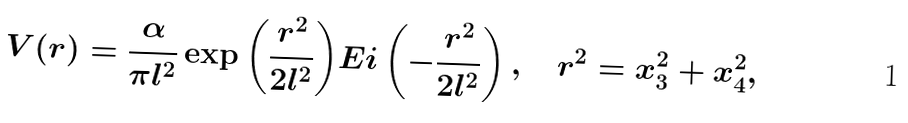<formula> <loc_0><loc_0><loc_500><loc_500>V ( { r } ) = \frac { \alpha } { \pi l ^ { 2 } } \exp { \left ( \frac { r ^ { 2 } } { 2 l ^ { 2 } } \right ) } E i \left ( - \frac { r ^ { 2 } } { 2 l ^ { 2 } } \right ) , \quad r ^ { 2 } = x ^ { 2 } _ { 3 } + x ^ { 2 } _ { 4 } ,</formula> 